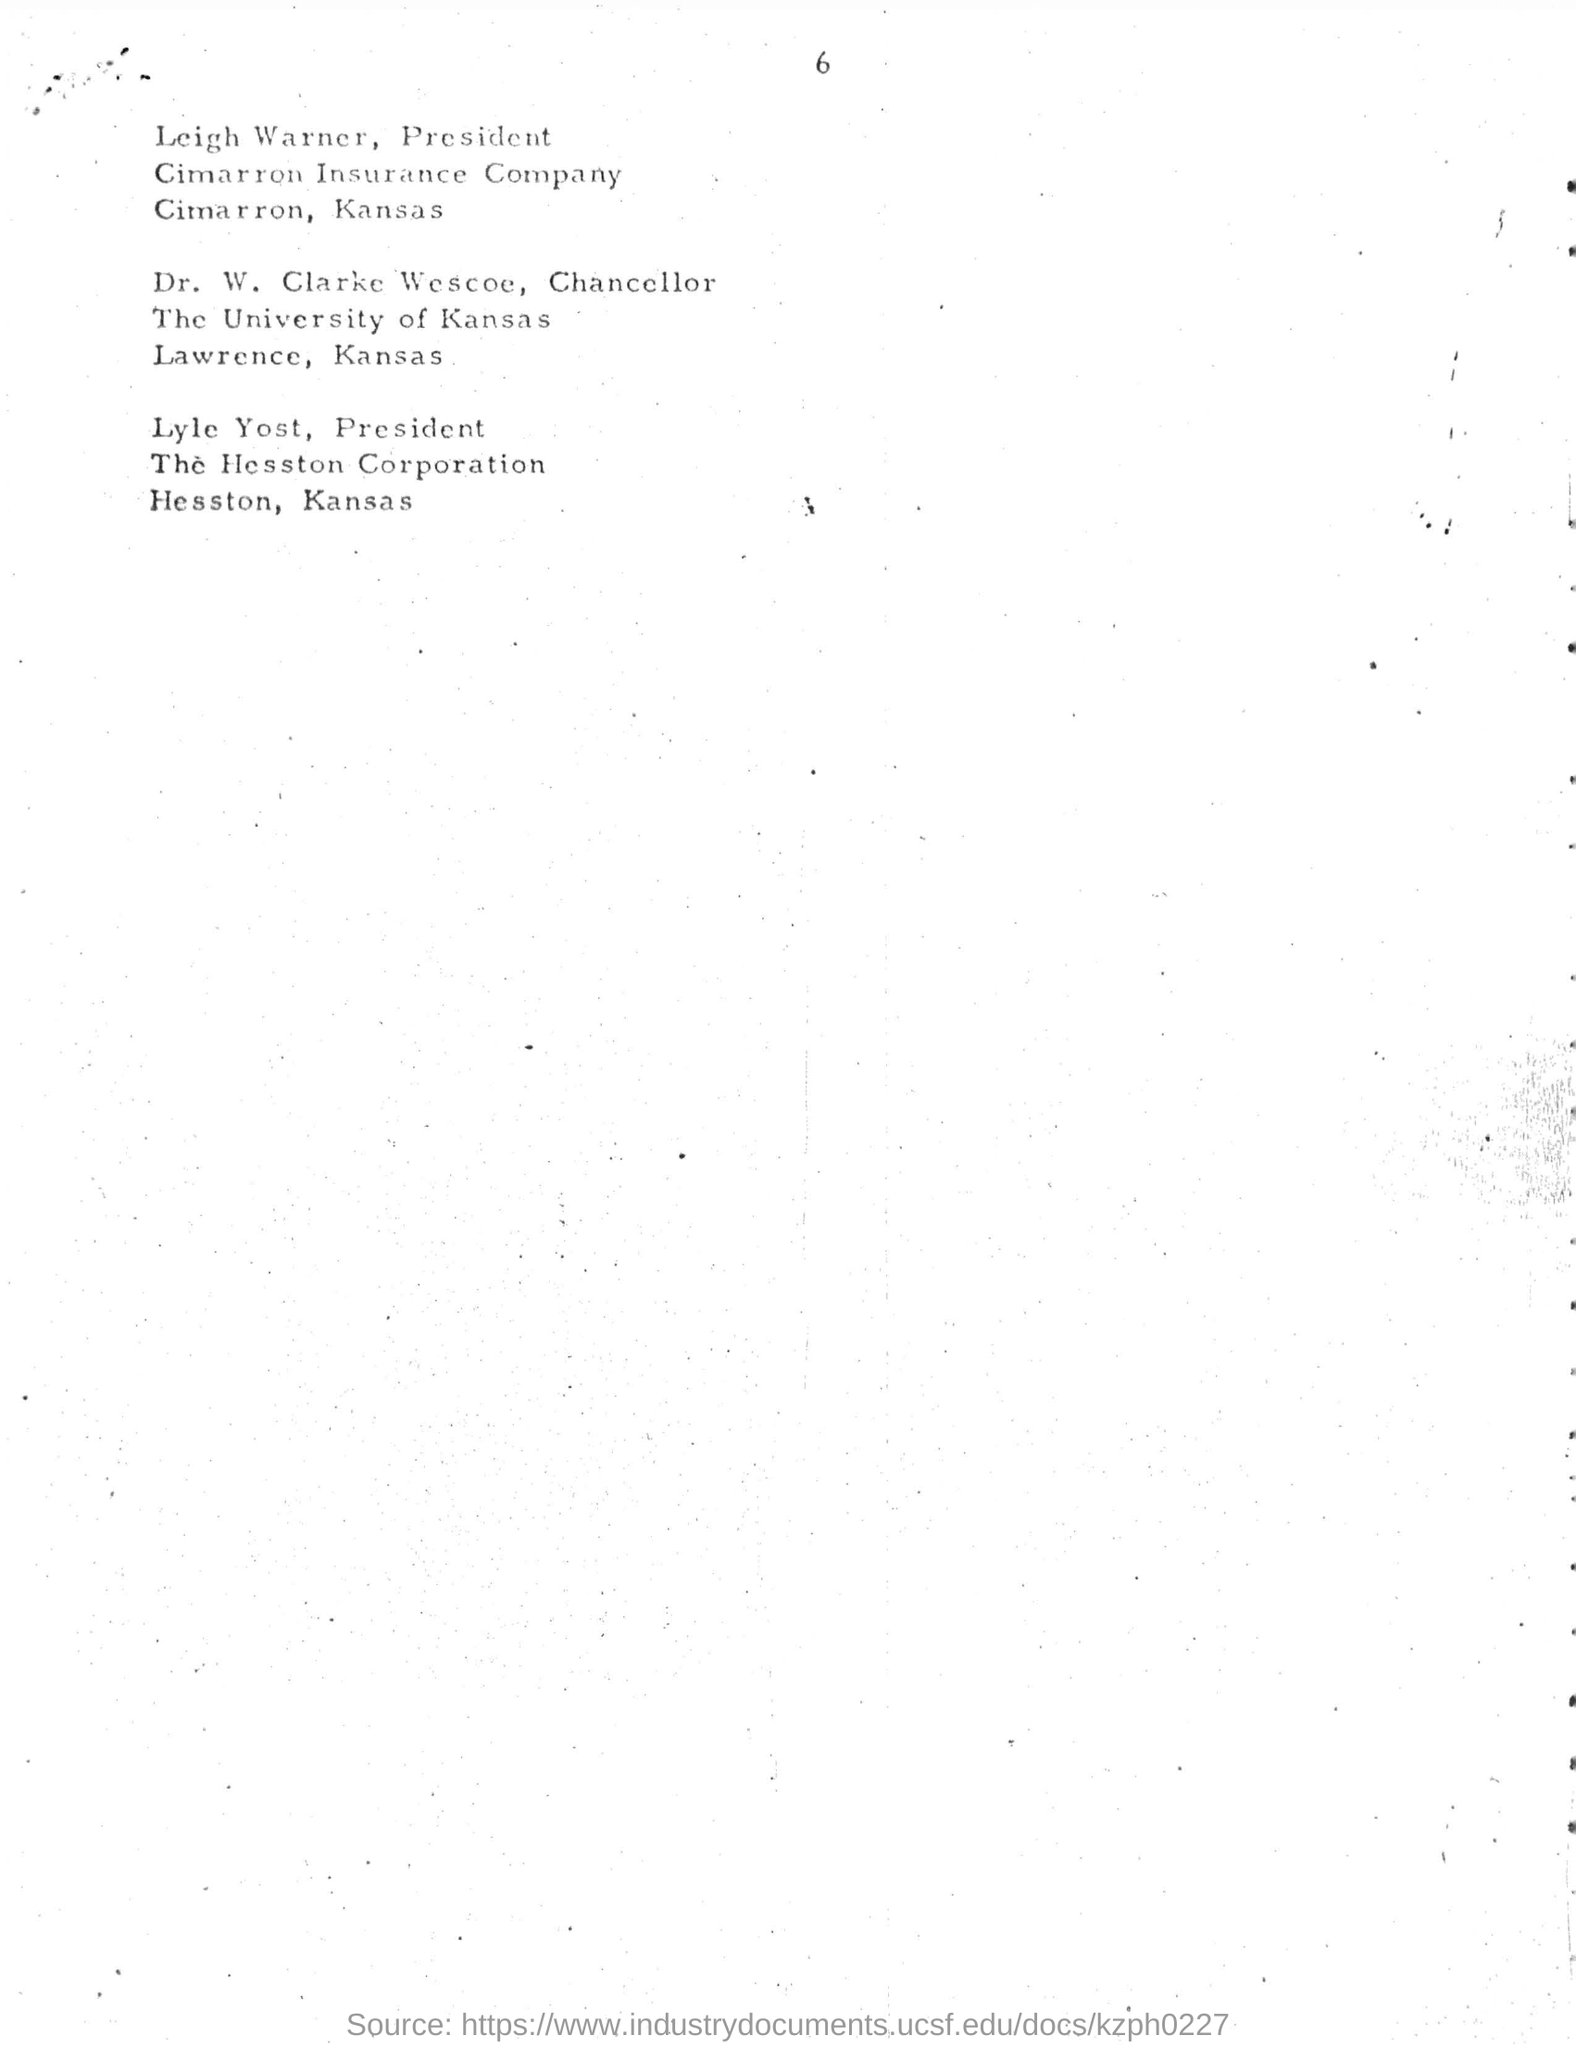Who is the president of cimarron insurance company?
Offer a terse response. Leigh Warner. What is the location of cimarron insurance company?
Offer a terse response. Cimarron, Kansas. Who is designated as chancellor?
Give a very brief answer. Dr. W. Clarke Wescoe. In which university dr.w. clarke wescoe was designated as chancellor?
Ensure brevity in your answer.  The university of kansas. Where is "the university of kansas "is located?
Offer a terse response. Lawrence, Kansas. Who is designated as president from hesston corporation ?
Offer a very short reply. Lyle yost. In which city "the hesston corporation" is situated?
Provide a short and direct response. Kansas. 